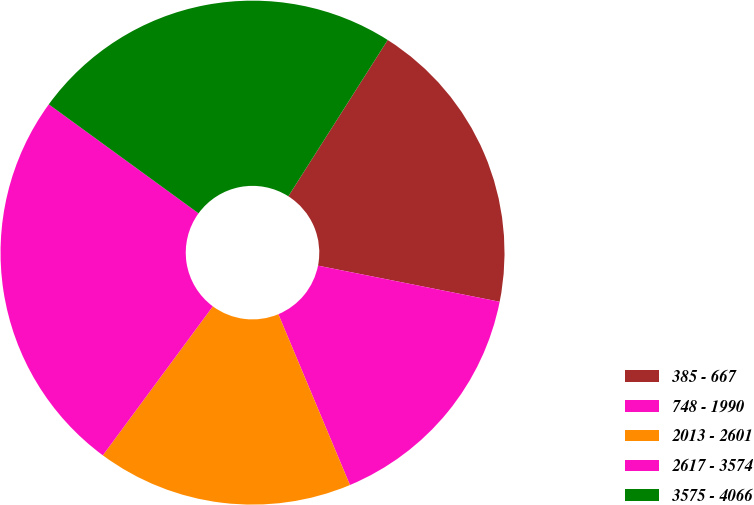<chart> <loc_0><loc_0><loc_500><loc_500><pie_chart><fcel>385 - 667<fcel>748 - 1990<fcel>2013 - 2601<fcel>2617 - 3574<fcel>3575 - 4066<nl><fcel>19.11%<fcel>15.56%<fcel>16.44%<fcel>24.89%<fcel>24.0%<nl></chart> 